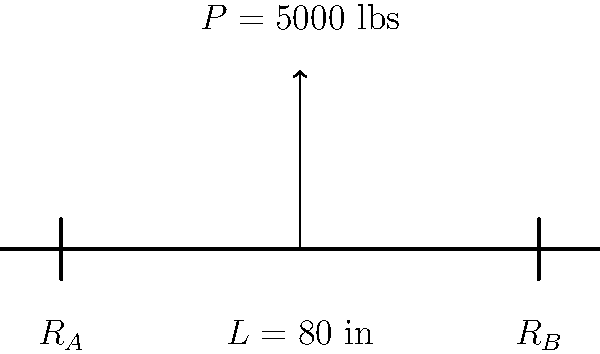Your granddaughter's Girl Scout troop is building a model bridge for a science fair project. They've created a simple beam design and need help calculating the maximum load it can support. The beam is 80 inches long and supported at both ends. If a single concentrated load $P = 5000$ lbs is applied at the center of the beam, what is the maximum bending moment $M_{max}$ (in lb-in) experienced by the beam? Let's approach this step-by-step:

1) For a simply supported beam with a concentrated load at the center, the maximum bending moment occurs at the center of the beam.

2) The formula for the maximum bending moment in this case is:

   $$M_{max} = \frac{PL}{4}$$

   Where:
   $P$ is the concentrated load
   $L$ is the length of the beam

3) We're given:
   $P = 5000$ lbs
   $L = 80$ inches

4) Let's substitute these values into our formula:

   $$M_{max} = \frac{5000 \text{ lbs} \times 80 \text{ in}}{4}$$

5) Now, let's calculate:

   $$M_{max} = \frac{400,000 \text{ lb-in}}{4} = 100,000 \text{ lb-in}$$

Therefore, the maximum bending moment experienced by the beam is 100,000 lb-in.
Answer: 100,000 lb-in 